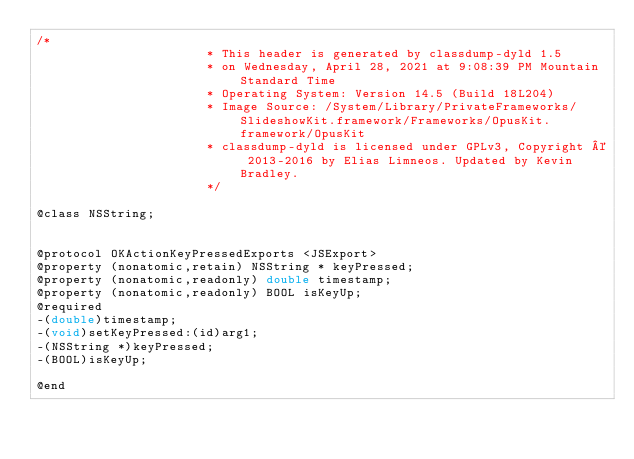<code> <loc_0><loc_0><loc_500><loc_500><_C_>/*
                       * This header is generated by classdump-dyld 1.5
                       * on Wednesday, April 28, 2021 at 9:08:39 PM Mountain Standard Time
                       * Operating System: Version 14.5 (Build 18L204)
                       * Image Source: /System/Library/PrivateFrameworks/SlideshowKit.framework/Frameworks/OpusKit.framework/OpusKit
                       * classdump-dyld is licensed under GPLv3, Copyright © 2013-2016 by Elias Limneos. Updated by Kevin Bradley.
                       */

@class NSString;


@protocol OKActionKeyPressedExports <JSExport>
@property (nonatomic,retain) NSString * keyPressed; 
@property (nonatomic,readonly) double timestamp; 
@property (nonatomic,readonly) BOOL isKeyUp; 
@required
-(double)timestamp;
-(void)setKeyPressed:(id)arg1;
-(NSString *)keyPressed;
-(BOOL)isKeyUp;

@end

</code> 